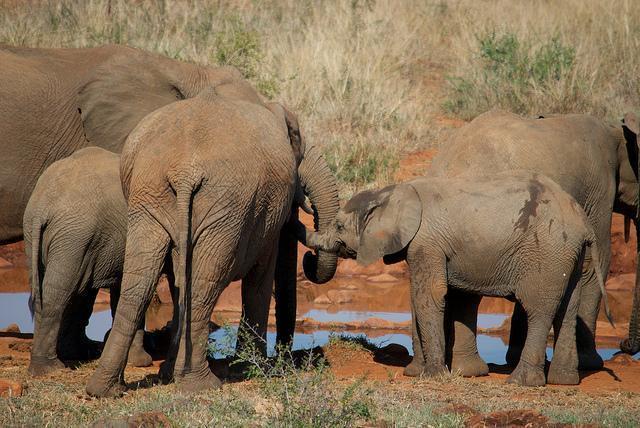How many elephants?
Give a very brief answer. 5. How many full grown elephants are visible?
Give a very brief answer. 3. How many elephants are standing in water?
Give a very brief answer. 0. How many elephants in this picture?
Give a very brief answer. 5. How many elephants are in the picture?
Give a very brief answer. 5. How many elephants are there?
Give a very brief answer. 5. 